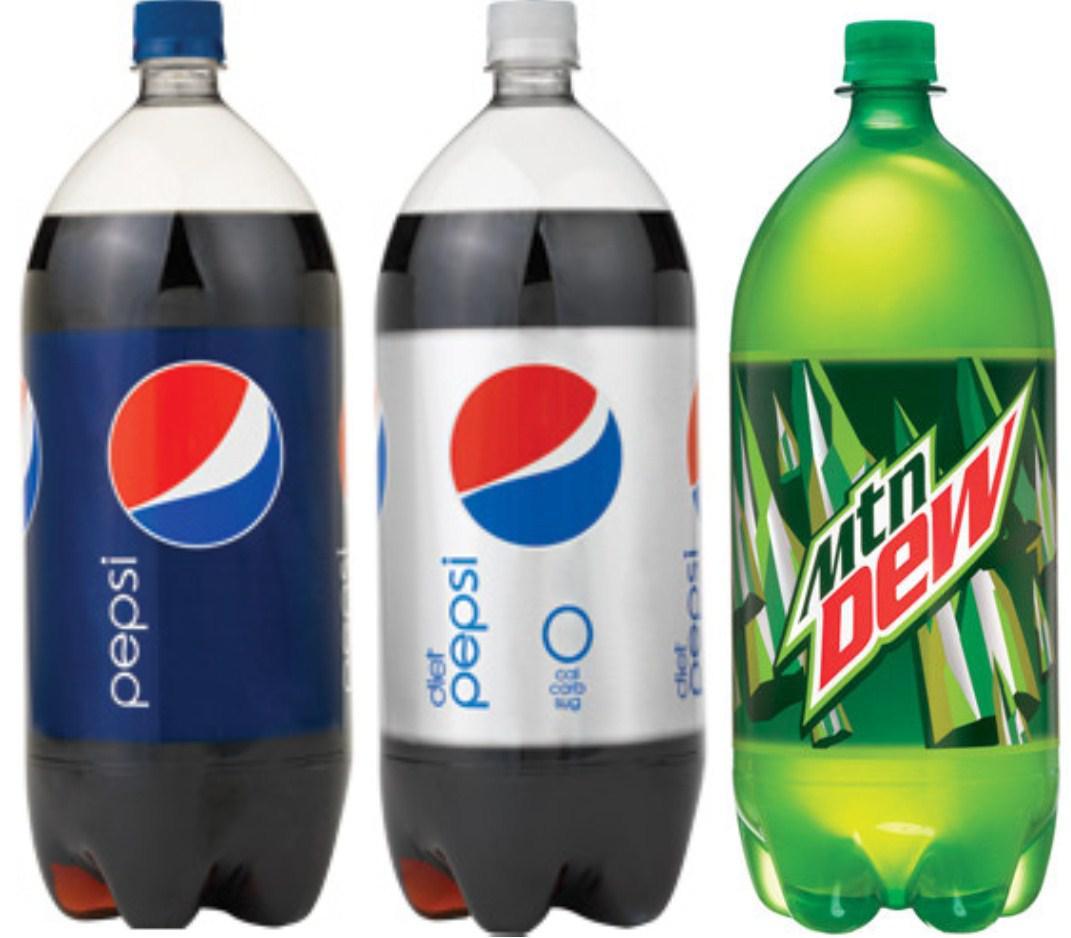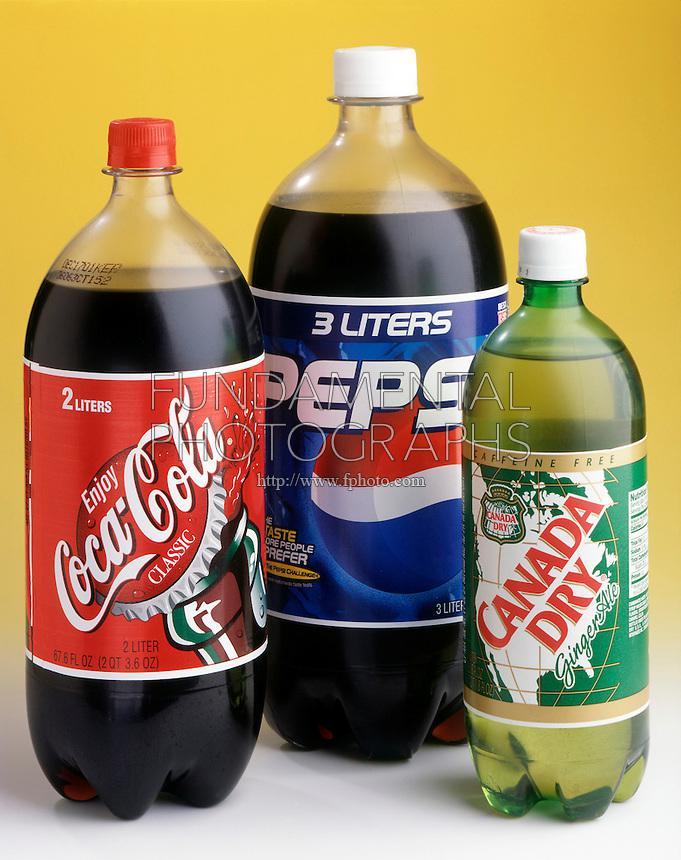The first image is the image on the left, the second image is the image on the right. Given the left and right images, does the statement "There are fewer than seven bottles in total." hold true? Answer yes or no. Yes. The first image is the image on the left, the second image is the image on the right. Assess this claim about the two images: "No image contains more than four bottles, and the left image shows a row of three bottles that aren't overlapping.". Correct or not? Answer yes or no. Yes. 